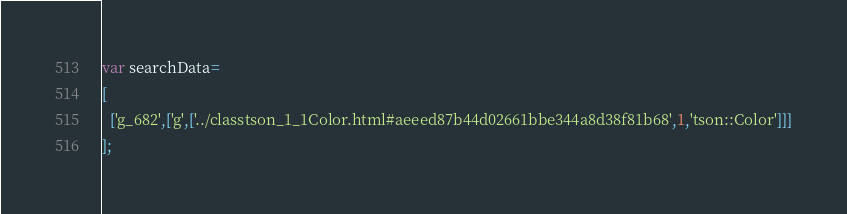Convert code to text. <code><loc_0><loc_0><loc_500><loc_500><_JavaScript_>var searchData=
[
  ['g_682',['g',['../classtson_1_1Color.html#aeeed87b44d02661bbe344a8d38f81b68',1,'tson::Color']]]
];
</code> 